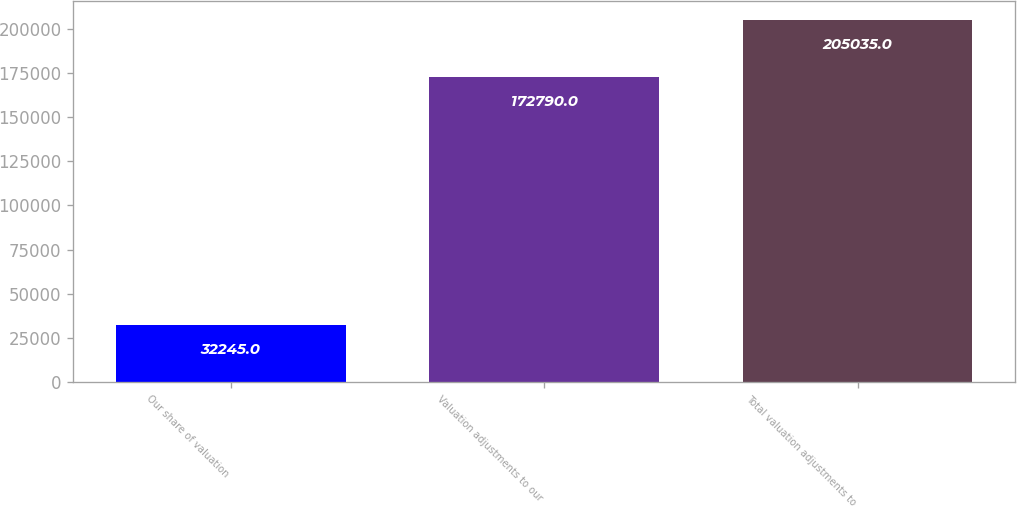Convert chart. <chart><loc_0><loc_0><loc_500><loc_500><bar_chart><fcel>Our share of valuation<fcel>Valuation adjustments to our<fcel>Total valuation adjustments to<nl><fcel>32245<fcel>172790<fcel>205035<nl></chart> 